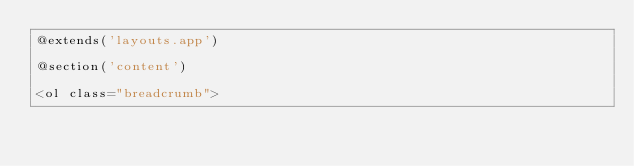<code> <loc_0><loc_0><loc_500><loc_500><_PHP_>@extends('layouts.app')

@section('content')

<ol class="breadcrumb"></code> 